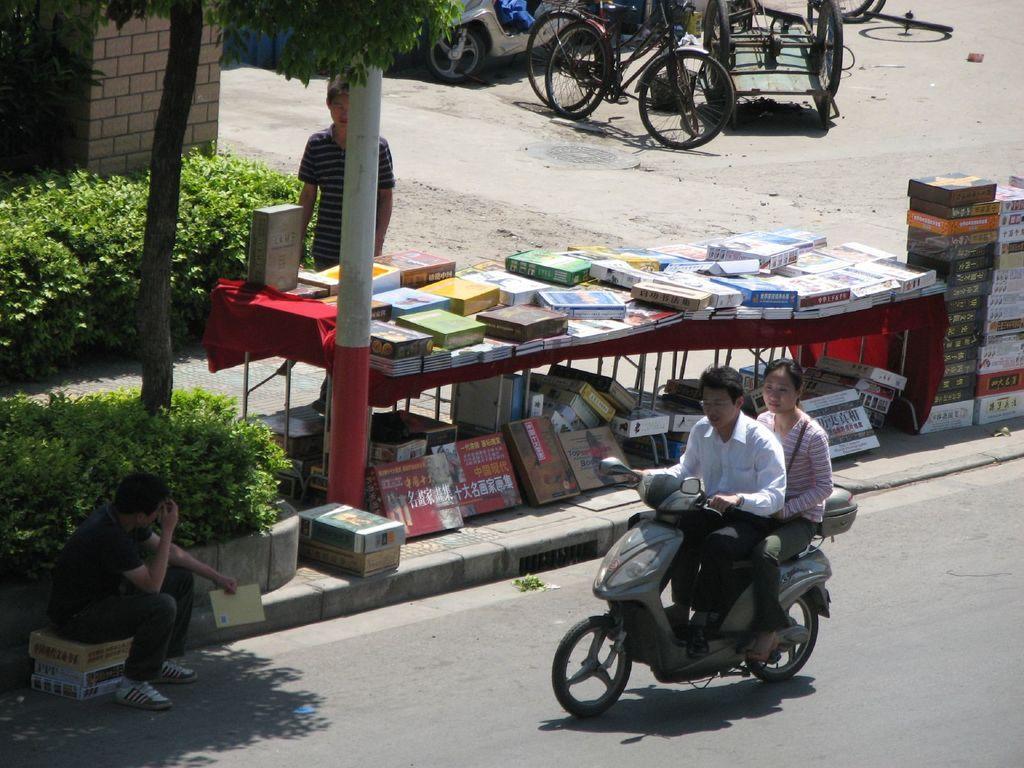Can you describe this image briefly? In this image there is a road, on that road there is a bike, on that bike there is a man and a woman are sitting, beside the road there is a footpath, on that footpath there are tables, on that tables there are few items, under the table and beside the table there are few boxes and there are trees and plants, beside the footpath there is a man sitting on boxes, in the background there are bicycles, scooters and a man standing behind a table. 